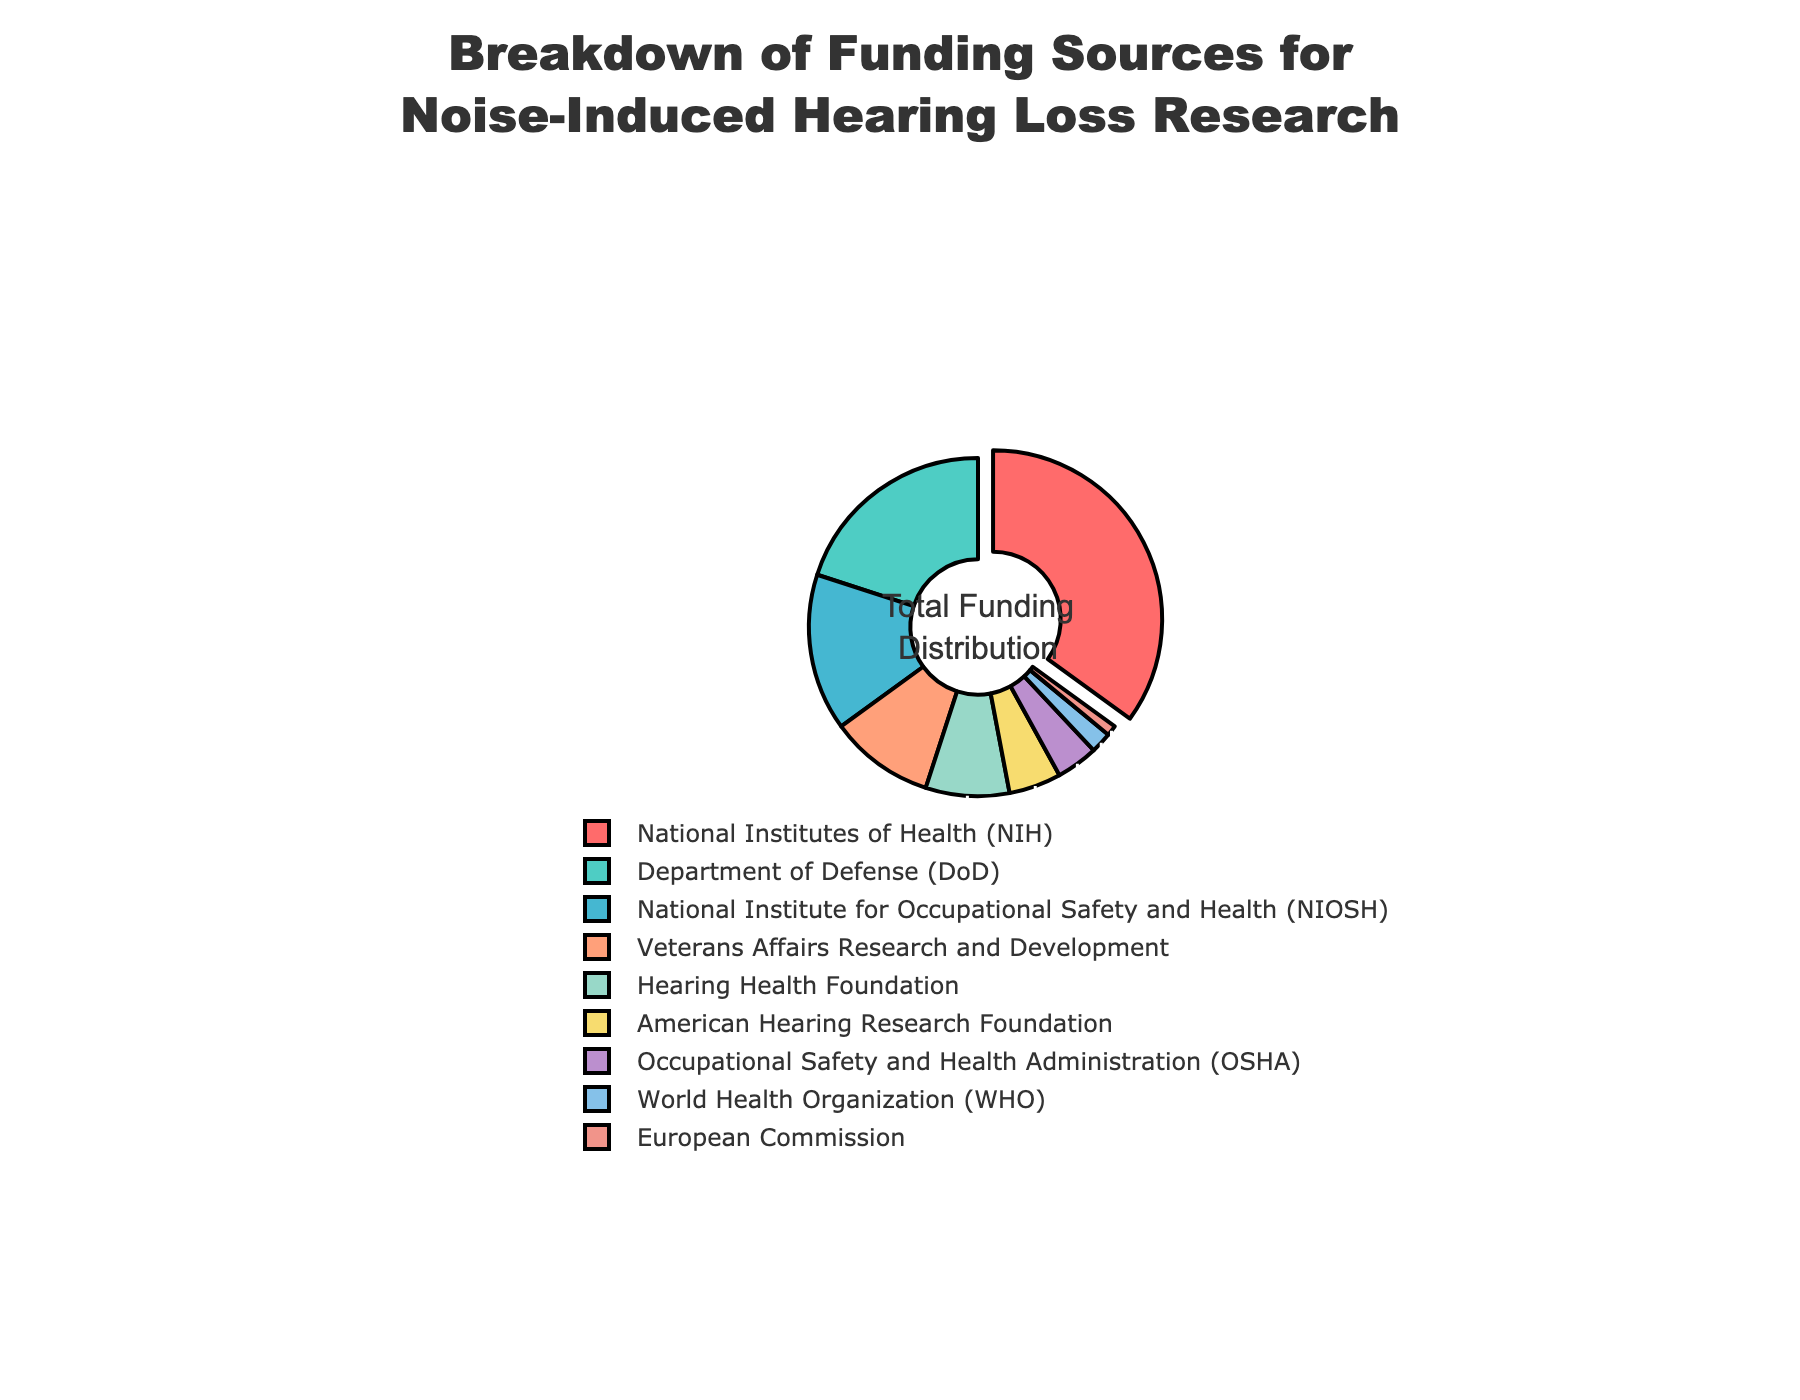What percentage of funding comes from the National Institutes of Health (NIH)? Locate the section labeled "National Institutes of Health (NIH)" in the pie chart and read the percentage value.
Answer: 35% What is the total percentage of funding provided by the Department of Defense (DoD) and the National Institute for Occupational Safety and Health (NIOSH)? First, find the percentages for the Department of Defense (20%) and the National Institute for Occupational Safety and Health (15%). Add these values together: 20% + 15% = 35%.
Answer: 35% Which funding source contributes less than 5% to the total funding? In the pie chart, identify the sections with percentages less than 5%. The sections for Occupational Safety and Health Administration (4%), World Health Organization (2%), and European Commission (1%) all meet this criterion.
Answer: Occupational Safety and Health Administration (4%), World Health Organization (2%), European Commission (1%) Compare the funding contribution between Veterans Affairs Research and Development and the American Hearing Research Foundation. Which one is larger? Find the percentages for Veterans Affairs Research and Development (10%) and the American Hearing Research Foundation (5%). Since 10% is greater than 5%, Veterans Affairs Research and Development has a larger contribution.
Answer: Veterans Affairs Research and Development If you combine the funding from the Hearing Health Foundation and the American Hearing Research Foundation, what percentage of the total funding do they make up? The percentages for the Hearing Health Foundation and the American Hearing Research Foundation are 8% and 5% respectively. Add these values together: 8% + 5% = 13%.
Answer: 13% What color is used to represent the section with the highest funding percentage in the pie chart? Identify the section with the highest funding percentage (National Institutes of Health, 35%) in the pie chart and note the color used for this section.
Answer: Red What is the difference in funding percentage between the National Institute for Occupational Safety and Health (NIOSH) and Veterans Affairs Research and Development? Find the percentages for the National Institute for Occupational Safety and Health (15%) and Veterans Affairs Research and Development (10%). Calculate the difference: 15% - 10% = 5%.
Answer: 5% Rank the top three funding sources based on their contribution percentages. Identify the three sections with the highest percentages: National Institutes of Health (35%), Department of Defense (20%), and National Institute for Occupational Safety and Health (15%). Rank them in descending order.
Answer: 1. National Institutes of Health 2. Department of Defense 3. National Institute for Occupational Safety and Health Which funding source contributes the least to the total funding? Find the section with the smallest percentage value in the pie chart. The European Commission contributes the least at 1%.
Answer: European Commission What is the average percentage of funding from the Department of Defense (DoD), Veterans Affairs Research and Development, and the European Commission? First, find the percentages for the Department of Defense (20%), Veterans Affairs Research and Development (10%), and the European Commission (1%). Add these values together: 20% + 10% + 1% = 31%. Divide by the number of sources (3): 31% / 3 ≈ 10.33%.
Answer: 10.33% 